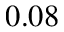<formula> <loc_0><loc_0><loc_500><loc_500>0 . 0 8</formula> 